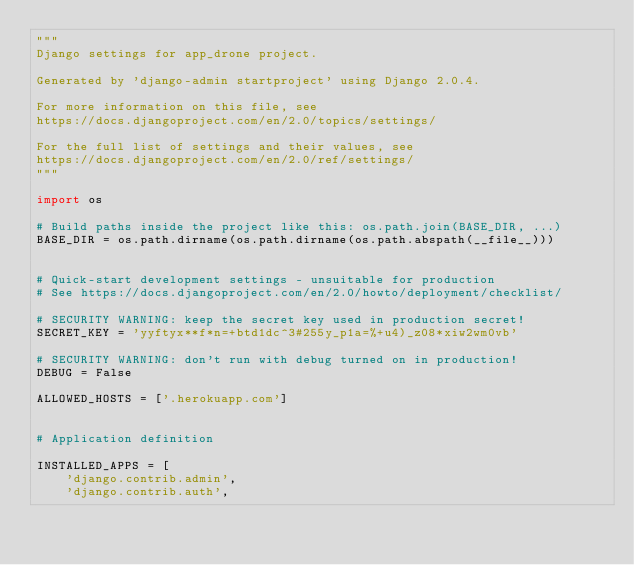<code> <loc_0><loc_0><loc_500><loc_500><_Python_>"""
Django settings for app_drone project.

Generated by 'django-admin startproject' using Django 2.0.4.

For more information on this file, see
https://docs.djangoproject.com/en/2.0/topics/settings/

For the full list of settings and their values, see
https://docs.djangoproject.com/en/2.0/ref/settings/
"""

import os

# Build paths inside the project like this: os.path.join(BASE_DIR, ...)
BASE_DIR = os.path.dirname(os.path.dirname(os.path.abspath(__file__)))


# Quick-start development settings - unsuitable for production
# See https://docs.djangoproject.com/en/2.0/howto/deployment/checklist/

# SECURITY WARNING: keep the secret key used in production secret!
SECRET_KEY = 'yyftyx**f*n=+btd1dc^3#255y_p1a=%+u4)_z08*xiw2wm0vb'

# SECURITY WARNING: don't run with debug turned on in production!
DEBUG = False

ALLOWED_HOSTS = ['.herokuapp.com']


# Application definition

INSTALLED_APPS = [
    'django.contrib.admin',
    'django.contrib.auth',</code> 